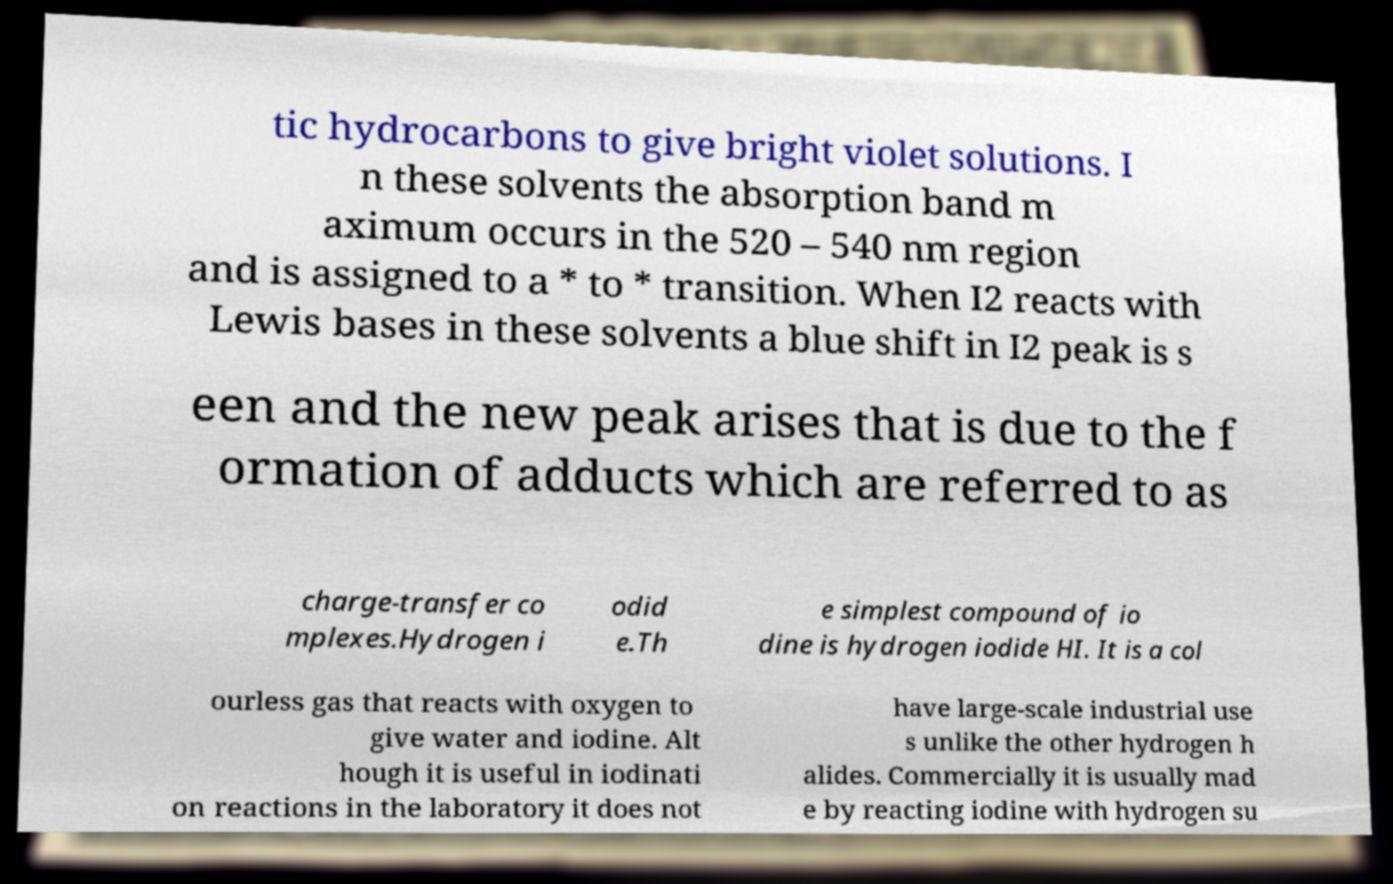Please identify and transcribe the text found in this image. tic hydrocarbons to give bright violet solutions. I n these solvents the absorption band m aximum occurs in the 520 – 540 nm region and is assigned to a * to * transition. When I2 reacts with Lewis bases in these solvents a blue shift in I2 peak is s een and the new peak arises that is due to the f ormation of adducts which are referred to as charge-transfer co mplexes.Hydrogen i odid e.Th e simplest compound of io dine is hydrogen iodide HI. It is a col ourless gas that reacts with oxygen to give water and iodine. Alt hough it is useful in iodinati on reactions in the laboratory it does not have large-scale industrial use s unlike the other hydrogen h alides. Commercially it is usually mad e by reacting iodine with hydrogen su 